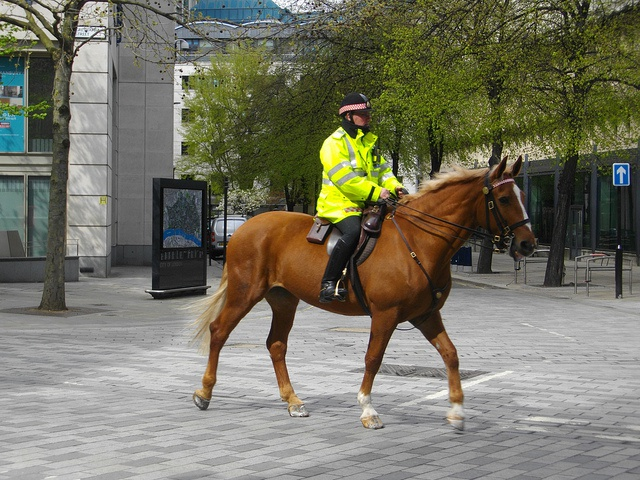Describe the objects in this image and their specific colors. I can see horse in darkgray, black, maroon, and brown tones, people in darkgray, black, yellow, and khaki tones, and car in darkgray, black, gray, and lightgray tones in this image. 